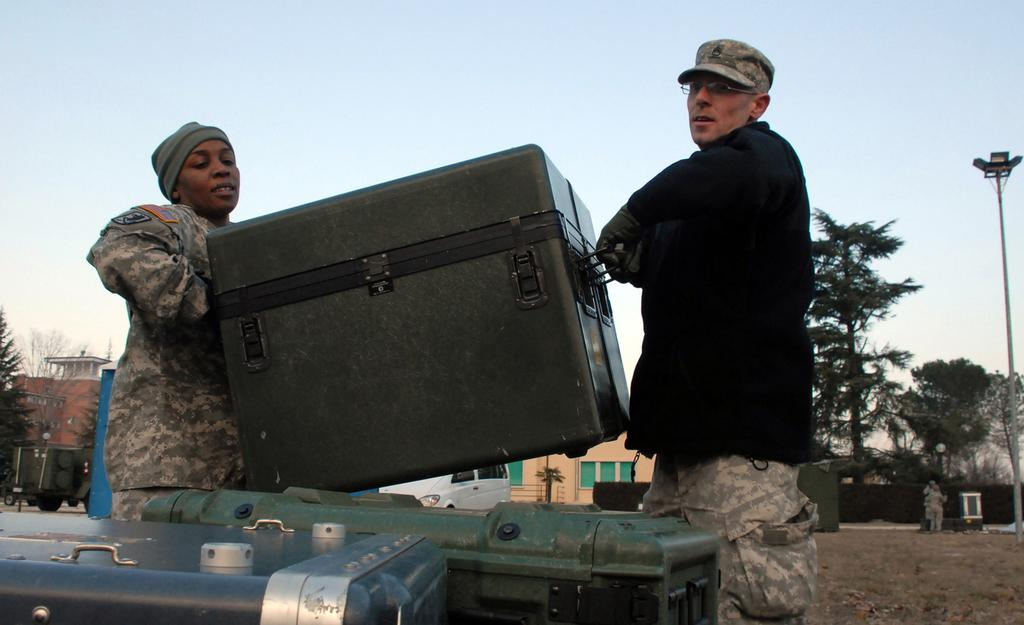How many people are in the image? There are two persons in the image. What are the two persons holding? The two persons are holding a box. What type of surface can be seen in the image? There is ground visible in the image. What other objects can be seen in the image besides the persons and the box? There are boxes, vehicles, houses, trees, and a pole visible in the image. What is visible in the background of the image? The sky is visible in the background of the image. What type of calendar is hanging on the pole in the image? There is no calendar present in the image; only a pole can be seen. What treatment is being administered to the vehicles in the image? There is no treatment being administered to the vehicles in the image; they are stationary and not undergoing any treatment. 